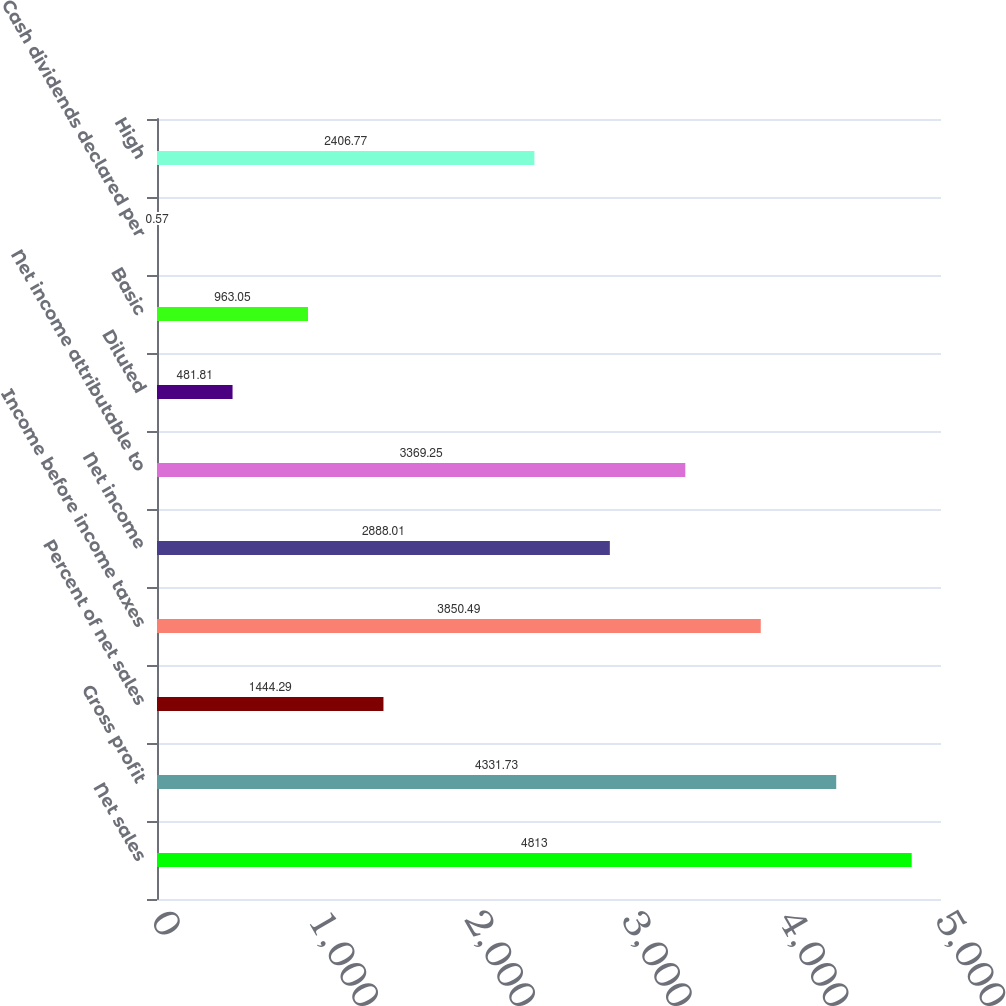<chart> <loc_0><loc_0><loc_500><loc_500><bar_chart><fcel>Net sales<fcel>Gross profit<fcel>Percent of net sales<fcel>Income before income taxes<fcel>Net income<fcel>Net income attributable to<fcel>Diluted<fcel>Basic<fcel>Cash dividends declared per<fcel>High<nl><fcel>4813<fcel>4331.73<fcel>1444.29<fcel>3850.49<fcel>2888.01<fcel>3369.25<fcel>481.81<fcel>963.05<fcel>0.57<fcel>2406.77<nl></chart> 